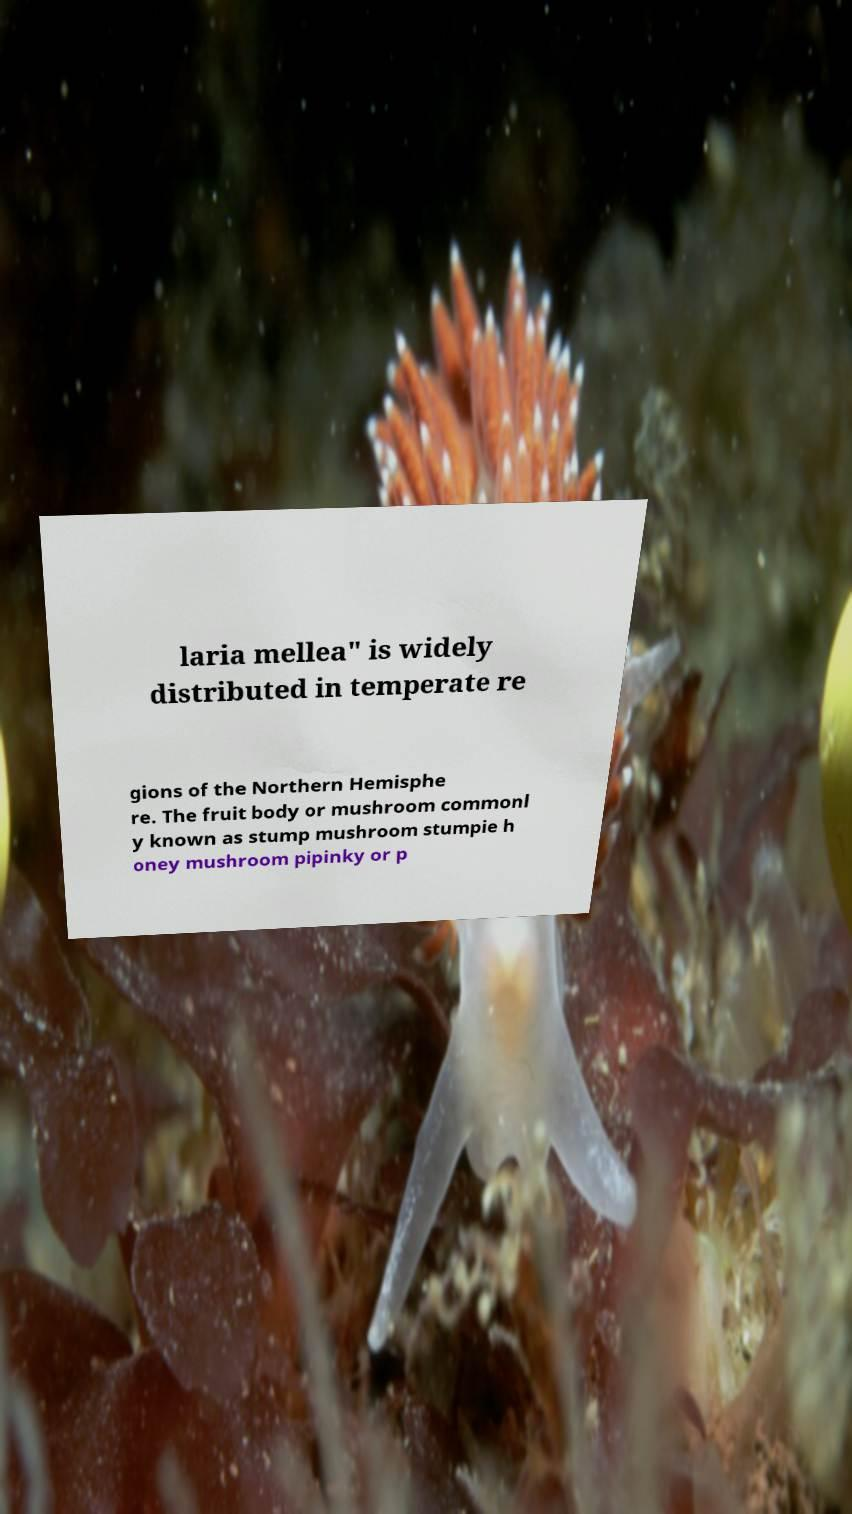Please read and relay the text visible in this image. What does it say? laria mellea" is widely distributed in temperate re gions of the Northern Hemisphe re. The fruit body or mushroom commonl y known as stump mushroom stumpie h oney mushroom pipinky or p 